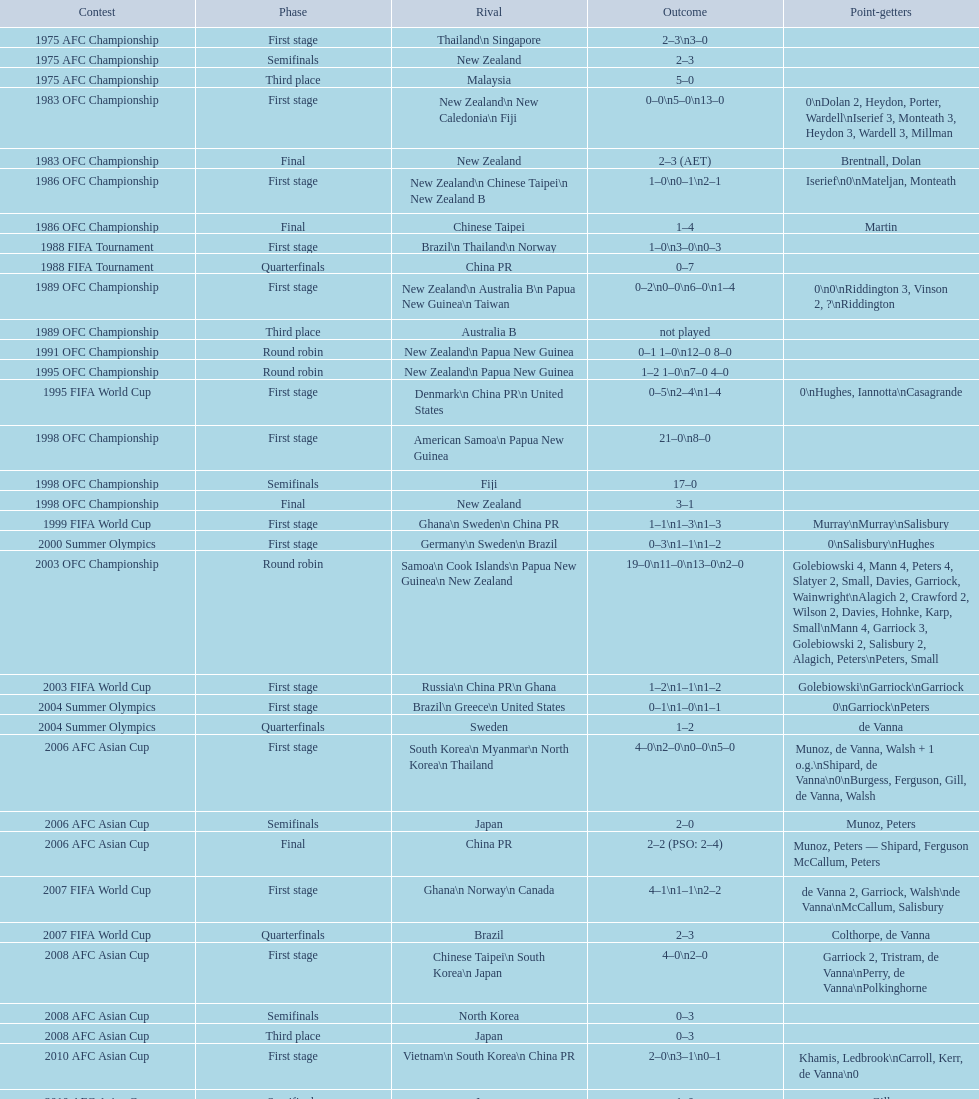What is the total number of competitions? 21. 